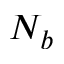<formula> <loc_0><loc_0><loc_500><loc_500>N _ { b }</formula> 